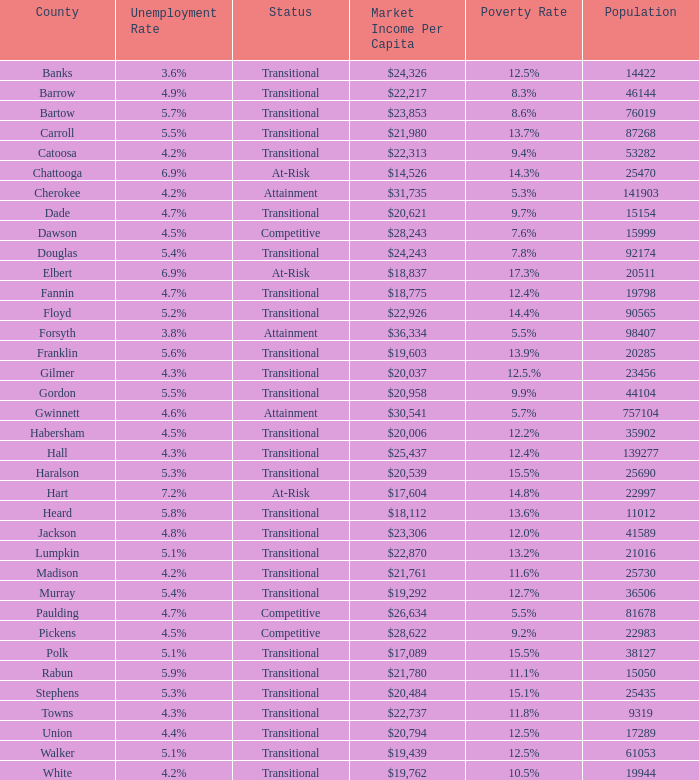What is the status of the county that has a 17.3% poverty rate? At-Risk. 